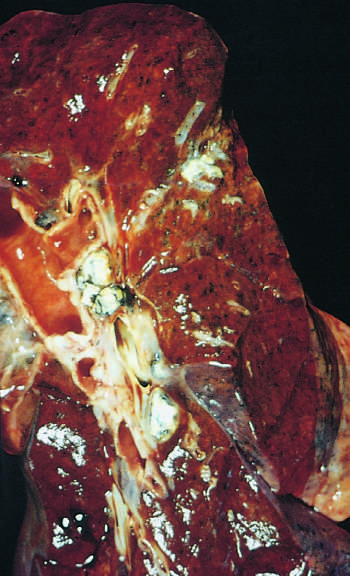re hilar lymph nodes with caseation seen left?
Answer the question using a single word or phrase. Yes 